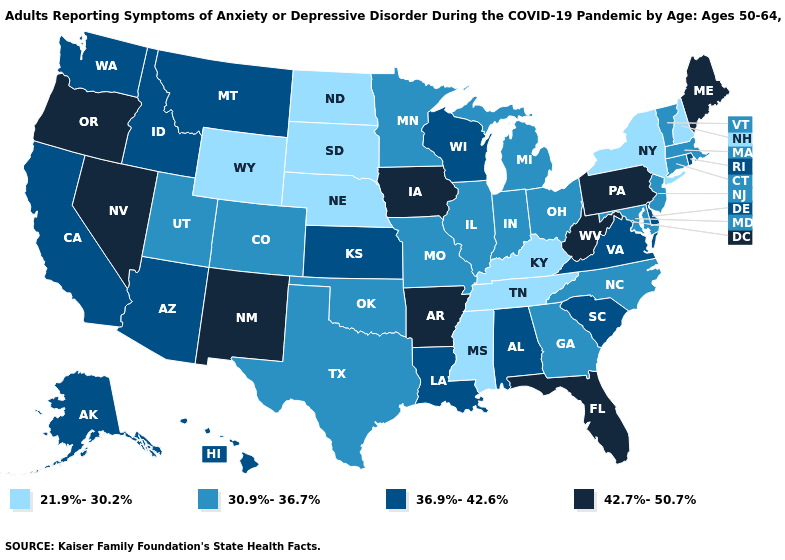What is the lowest value in the South?
Give a very brief answer. 21.9%-30.2%. Does Kentucky have the highest value in the South?
Concise answer only. No. Is the legend a continuous bar?
Write a very short answer. No. What is the lowest value in the USA?
Concise answer only. 21.9%-30.2%. Name the states that have a value in the range 21.9%-30.2%?
Keep it brief. Kentucky, Mississippi, Nebraska, New Hampshire, New York, North Dakota, South Dakota, Tennessee, Wyoming. What is the value of Massachusetts?
Concise answer only. 30.9%-36.7%. Does New York have the lowest value in the Northeast?
Keep it brief. Yes. What is the value of Colorado?
Quick response, please. 30.9%-36.7%. Among the states that border Delaware , which have the lowest value?
Quick response, please. Maryland, New Jersey. What is the value of Alabama?
Concise answer only. 36.9%-42.6%. Among the states that border Georgia , does Tennessee have the highest value?
Write a very short answer. No. Which states hav the highest value in the MidWest?
Keep it brief. Iowa. Does New Hampshire have the lowest value in the Northeast?
Keep it brief. Yes. What is the highest value in states that border North Carolina?
Short answer required. 36.9%-42.6%. Among the states that border Idaho , does Montana have the lowest value?
Write a very short answer. No. 